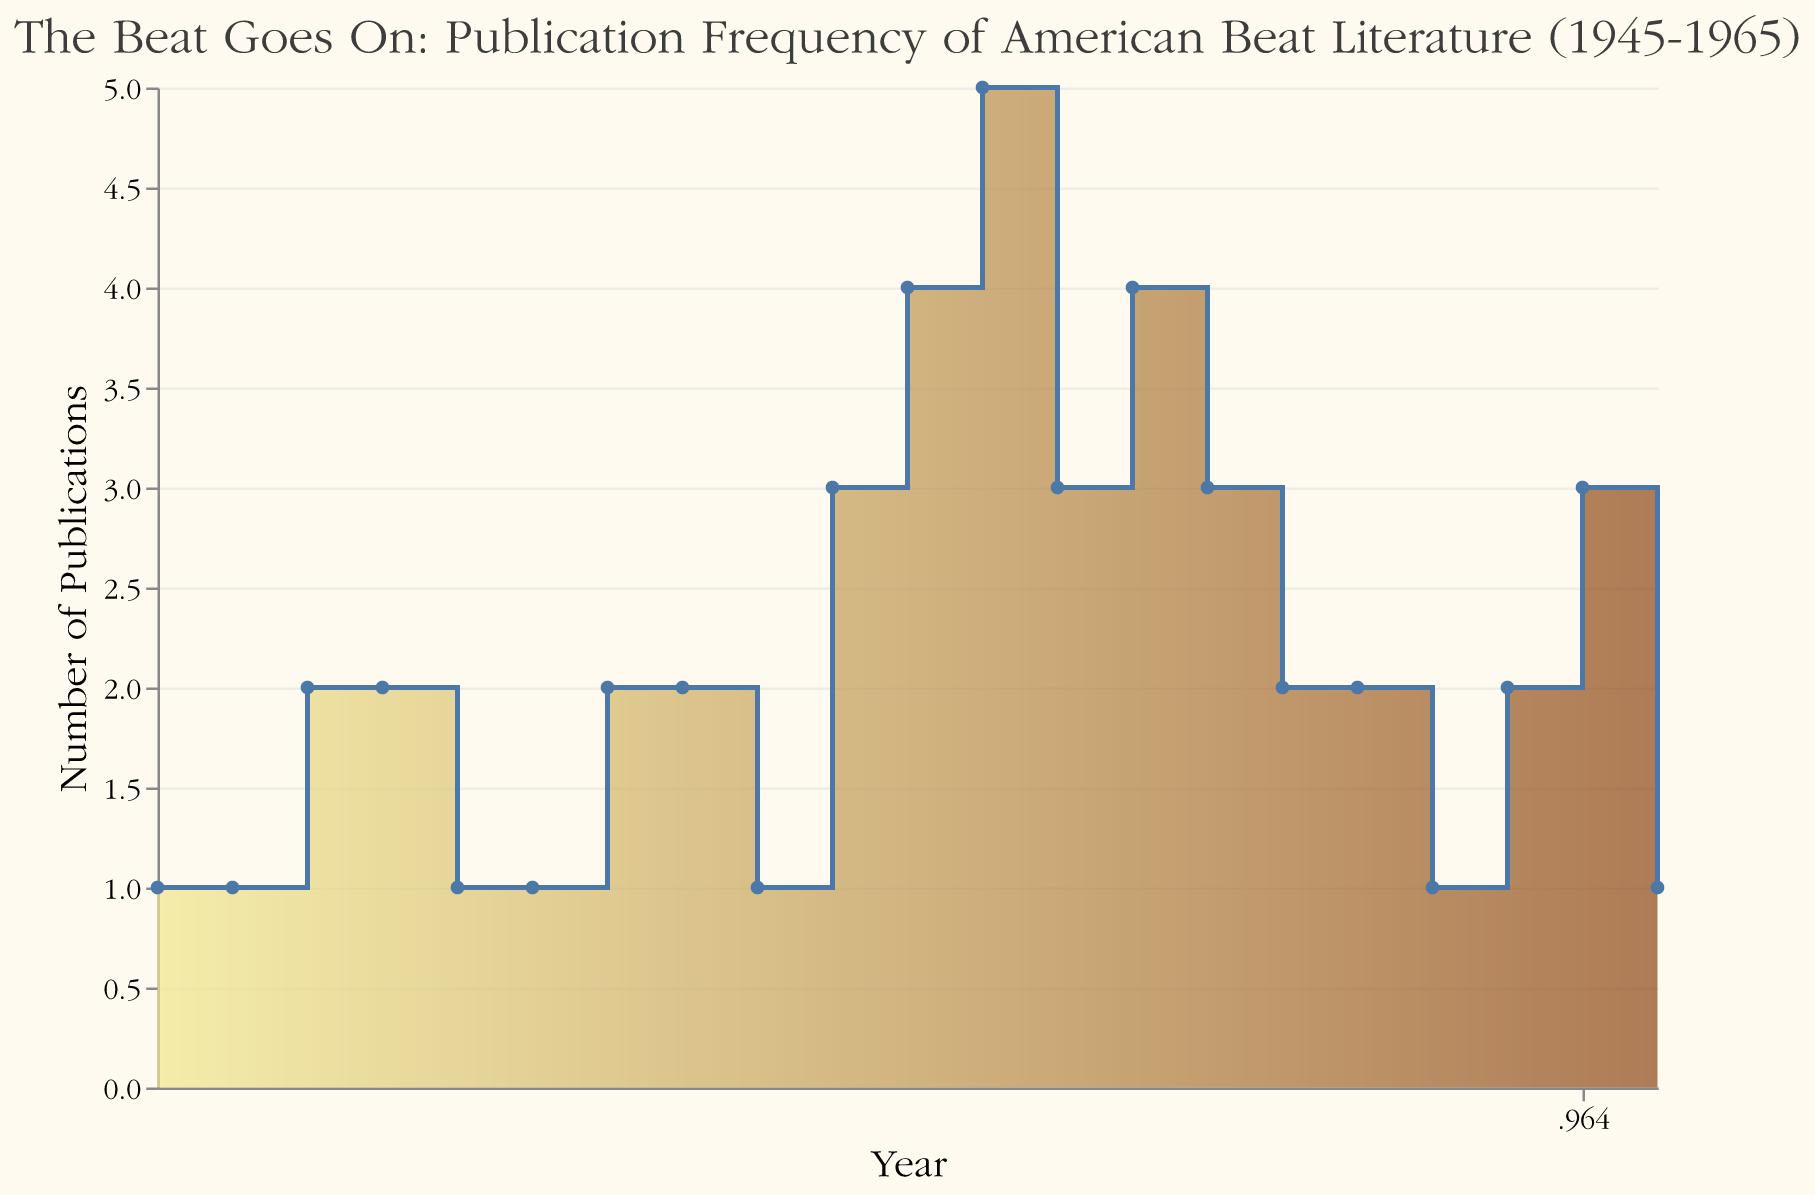What does the title of the chart convey? The title of the chart gives an indication of the main focus, which is the publication frequency of American Beat literature from 1945 to 1965. It helps set the context.
Answer: The Beat Goes On: Publication Frequency of American Beat Literature (1945-1965) What is the range of years displayed on the x-axis? The x-axis represents the years from 1945 to 1965, showing the time period over which the publication data is tracked.
Answer: 1945 to 1965 How many publications were there in 1956? By looking at the height of the step area at the year 1956, it can be determined that there were 5 publications in that year.
Answer: 5 In which year did the number of publications peak? The highest point in the step area chart corresponds to the year 1956, where the number of publications was at its peak.
Answer: 1956 Compare the number of publications in 1954 and 1964. Which year had more? By comparing the heights of the step areas for the years 1954 and 1964, it is seen that both years had the same number of publications, which is 3.
Answer: Both had 3 What are the colors used in the chart gradient? The chart uses two main colors in a gradient: at the lower end is a light yellow color, and at the higher end is a brown color.
Answer: Light yellow and brown What is the average number of publications per year between 1950 and 1960? To find the average, add the number of publications from 1950 to 1960 and divide by the number of years: (1+2+2+1+3+4+5+3+4+3+2)/11. This totals 30, and dividing by 11 gives approximately 2.73.
Answer: 2.73 Between which consecutive years did the number of publications decrease the most? By identifying the sharpest drop in the step area chart, the largest decrease happened between 1956 and 1957, where the publications went from 5 to 3, a decrease of 2.
Answer: 1956 to 1957 How does the publication frequency in 1960 compare to 1950? In both 1960 and 1950, the number of publications was the same, indicating no change in publication frequency between these two years.
Answer: The same Describe the overall trend in publication frequency from 1945 to 1965. There is a general increase in publication frequency after 1950, peaking at 1956, followed by some fluctuations and a subsequent decline towards the end of the period.
Answer: Increase, peak, then decline 